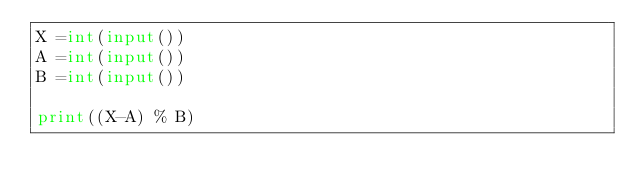Convert code to text. <code><loc_0><loc_0><loc_500><loc_500><_Python_>X =int(input())
A =int(input())
B =int(input())

print((X-A) % B)</code> 